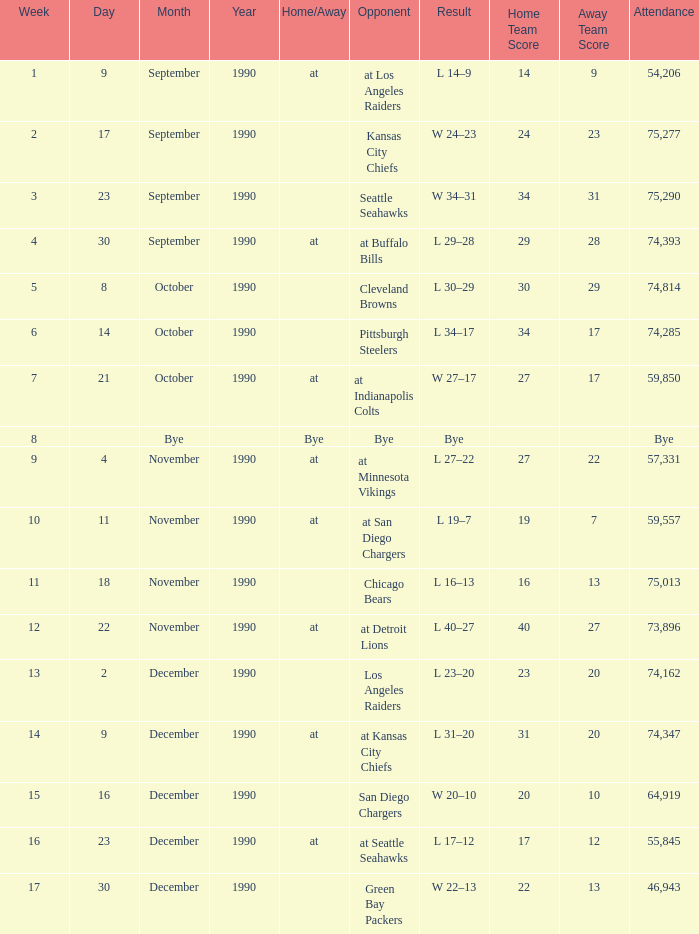Who is the opponent when the attendance is 57,331? At minnesota vikings. 